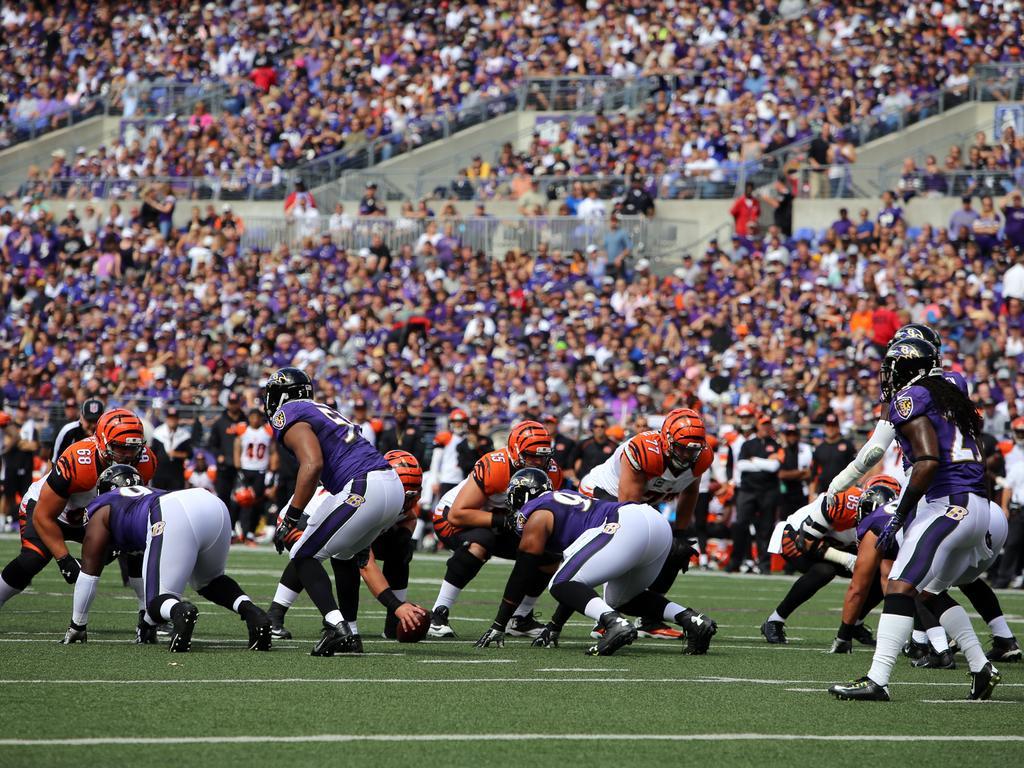Could you give a brief overview of what you see in this image? In this image I can see few players are wearing different color dresses. I can see a ball. Back I can see few railings and a group of people sitting. 